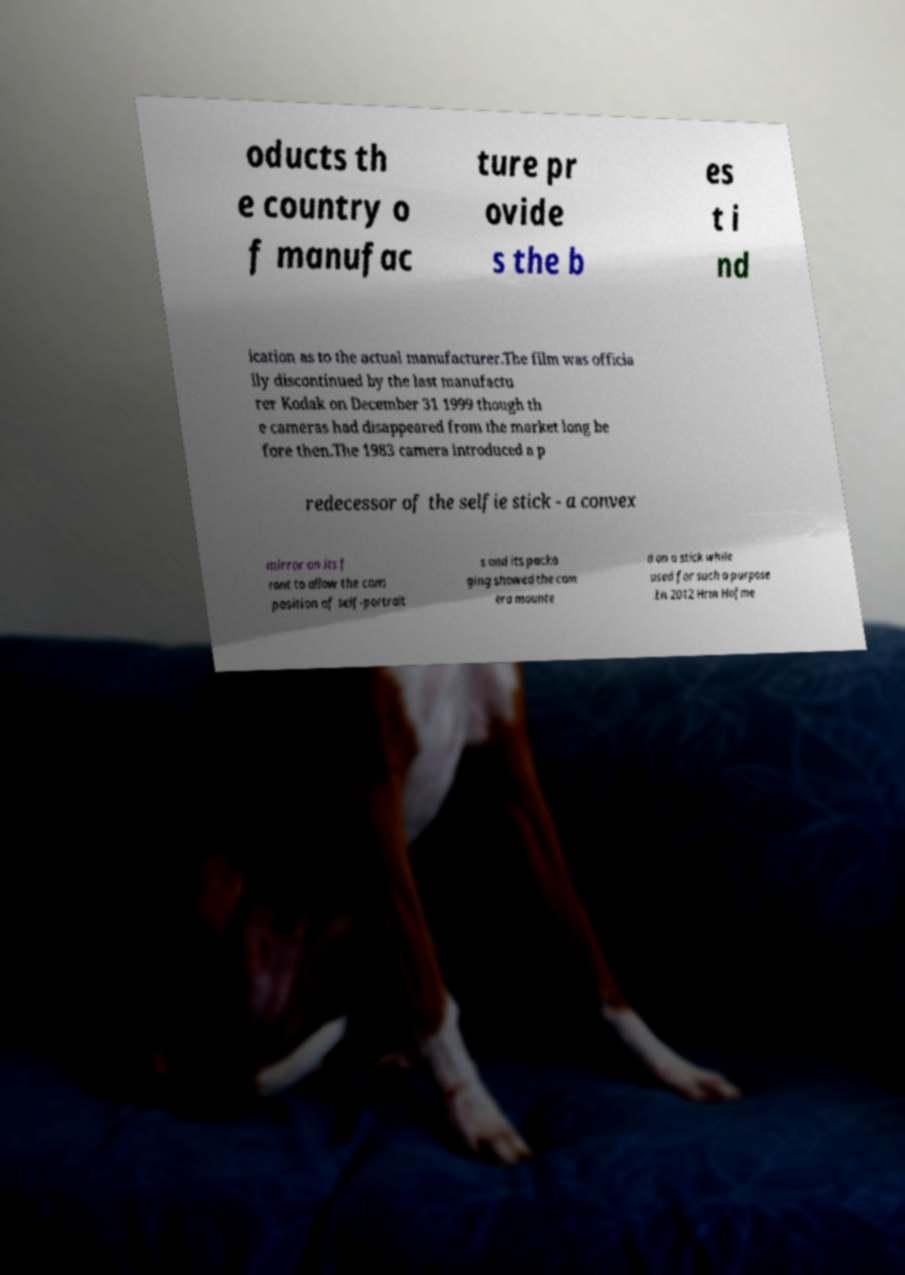Please read and relay the text visible in this image. What does it say? oducts th e country o f manufac ture pr ovide s the b es t i nd ication as to the actual manufacturer.The film was officia lly discontinued by the last manufactu rer Kodak on December 31 1999 though th e cameras had disappeared from the market long be fore then.The 1983 camera introduced a p redecessor of the selfie stick - a convex mirror on its f ront to allow the com position of self-portrait s and its packa ging showed the cam era mounte d on a stick while used for such a purpose .In 2012 Hrm Hofme 